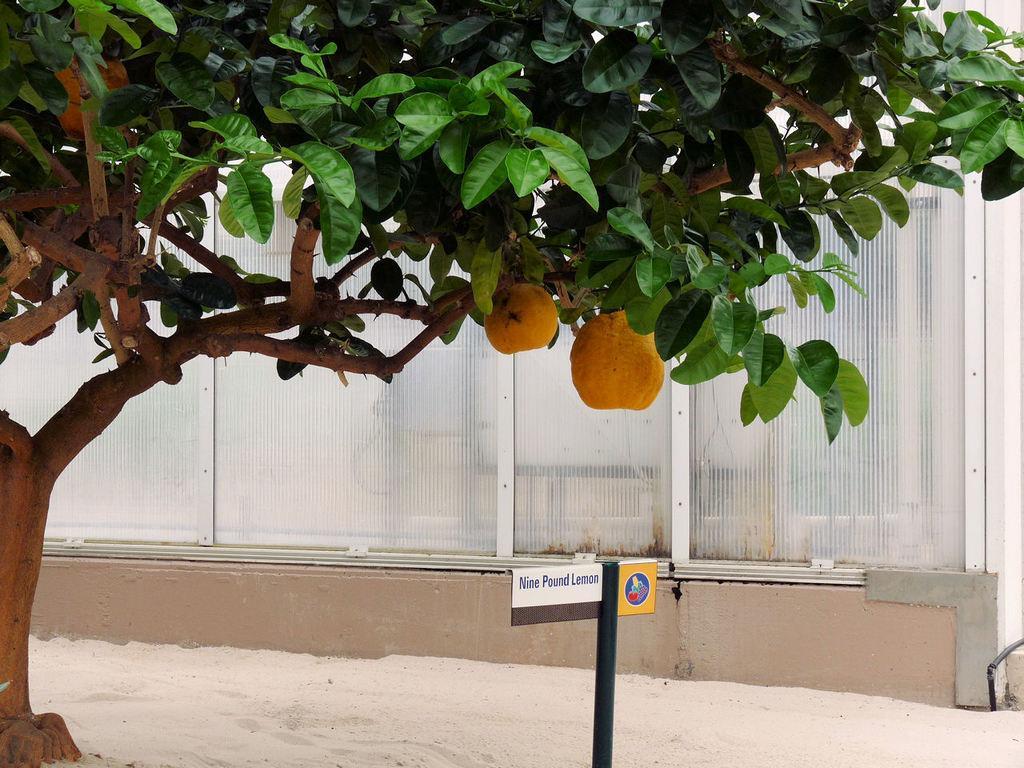In one or two sentences, can you explain what this image depicts? In this image I can see a tree which is brown and green in color and to it I can see few fruits which are orange in color. I can see the sand, a black colored pole with two boards and the building. 